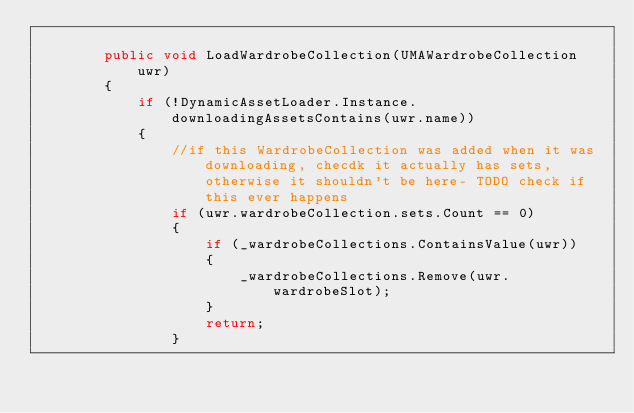<code> <loc_0><loc_0><loc_500><loc_500><_C#_>
        public void LoadWardrobeCollection(UMAWardrobeCollection uwr)
        {
            if (!DynamicAssetLoader.Instance.downloadingAssetsContains(uwr.name))
            {
                //if this WardrobeCollection was added when it was downloading, checdk it actually has sets, otherwise it shouldn't be here- TODO check if this ever happens
                if (uwr.wardrobeCollection.sets.Count == 0)
                {
                    if (_wardrobeCollections.ContainsValue(uwr))
                    {
                        _wardrobeCollections.Remove(uwr.wardrobeSlot);
                    }
                    return;
                }</code> 